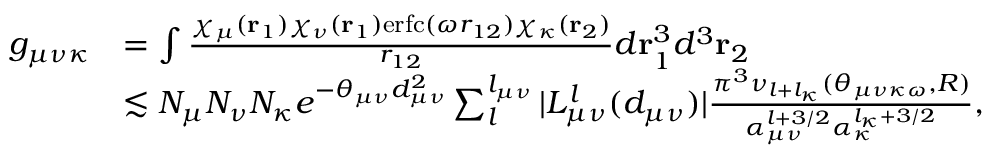<formula> <loc_0><loc_0><loc_500><loc_500>\begin{array} { r l } { g _ { \mu \nu \kappa } } & { = \int \frac { \chi _ { \mu } ( r _ { 1 } ) \chi _ { \nu } ( r _ { 1 } ) e r f c ( \omega r _ { 1 2 } ) \chi _ { \kappa } ( r _ { 2 } ) } { r _ { 1 2 } } d r _ { 1 } ^ { 3 } d ^ { 3 } r _ { 2 } } \\ & { \lesssim N _ { \mu } N _ { \nu } N _ { \kappa } e ^ { - \theta _ { \mu \nu } d _ { \mu \nu } ^ { 2 } } \sum _ { l } ^ { l _ { \mu \nu } } | L _ { \mu \nu } ^ { l } ( d _ { \mu \nu } ) | \frac { \pi ^ { 3 } \nu _ { l + l _ { \kappa } } ( \theta _ { \mu \nu \kappa \omega } , R ) } { \alpha _ { \mu \nu } ^ { l + 3 / 2 } \alpha _ { \kappa } ^ { l _ { \kappa } + 3 / 2 } } , } \end{array}</formula> 